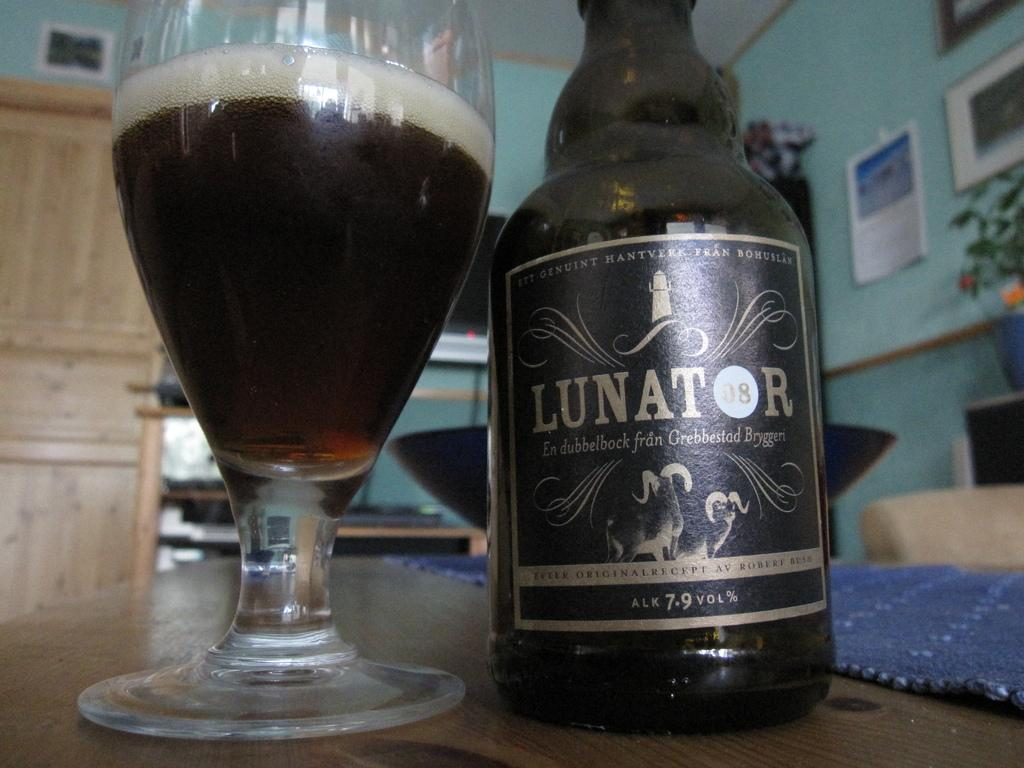<image>
Render a clear and concise summary of the photo. the bottle that has the word Lunator on it 